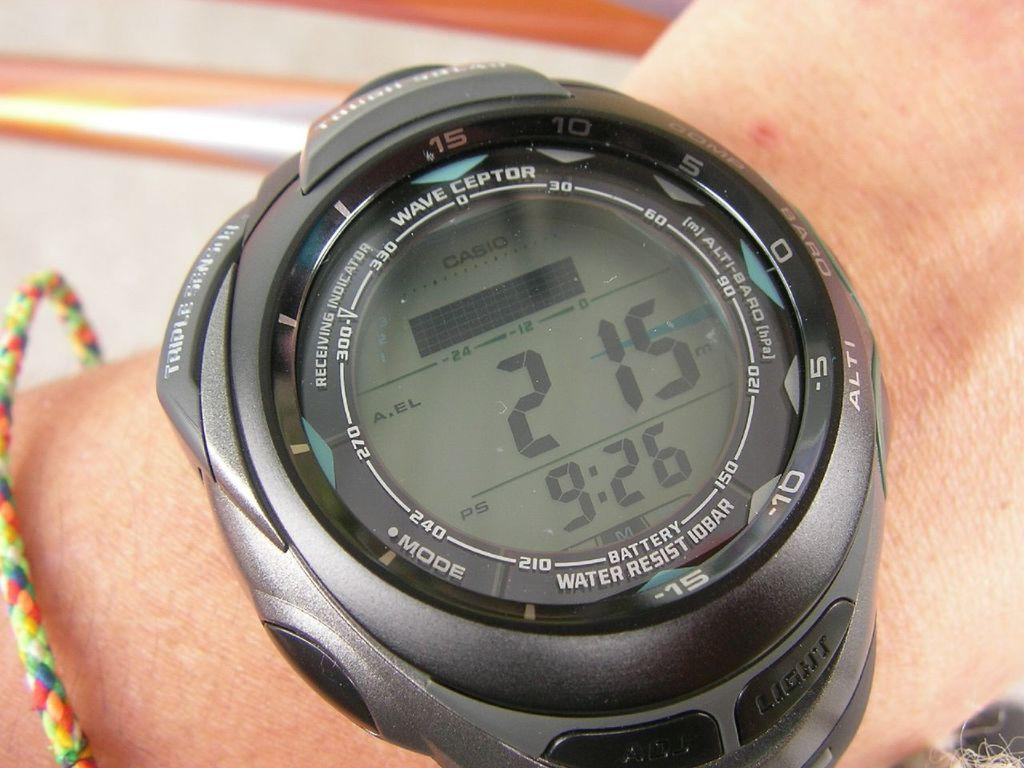<image>
Summarize the visual content of the image. The front of a black Casio watch has many different functions. 